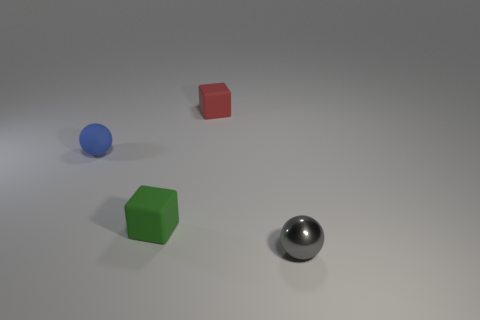Add 1 small blue matte balls. How many objects exist? 5 Add 4 small things. How many small things are left? 8 Add 1 small metallic spheres. How many small metallic spheres exist? 2 Subtract 0 gray blocks. How many objects are left? 4 Subtract all tiny blue matte objects. Subtract all tiny green matte things. How many objects are left? 2 